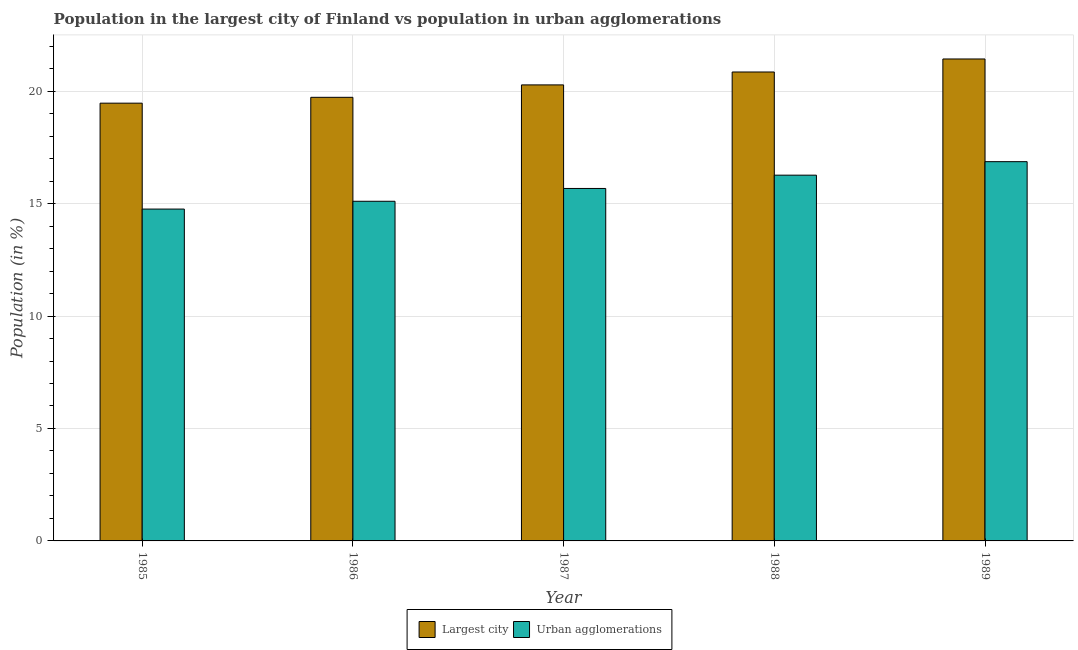Are the number of bars per tick equal to the number of legend labels?
Ensure brevity in your answer.  Yes. Are the number of bars on each tick of the X-axis equal?
Give a very brief answer. Yes. In how many cases, is the number of bars for a given year not equal to the number of legend labels?
Provide a succinct answer. 0. What is the population in the largest city in 1986?
Provide a short and direct response. 19.73. Across all years, what is the maximum population in urban agglomerations?
Give a very brief answer. 16.86. Across all years, what is the minimum population in urban agglomerations?
Your answer should be very brief. 14.76. In which year was the population in the largest city minimum?
Offer a very short reply. 1985. What is the total population in urban agglomerations in the graph?
Make the answer very short. 78.66. What is the difference between the population in urban agglomerations in 1988 and that in 1989?
Ensure brevity in your answer.  -0.6. What is the difference between the population in the largest city in 1985 and the population in urban agglomerations in 1989?
Give a very brief answer. -1.97. What is the average population in urban agglomerations per year?
Provide a succinct answer. 15.73. In the year 1986, what is the difference between the population in the largest city and population in urban agglomerations?
Give a very brief answer. 0. In how many years, is the population in the largest city greater than 4 %?
Give a very brief answer. 5. What is the ratio of the population in urban agglomerations in 1987 to that in 1989?
Your answer should be very brief. 0.93. Is the population in the largest city in 1987 less than that in 1988?
Your answer should be compact. Yes. What is the difference between the highest and the second highest population in urban agglomerations?
Provide a succinct answer. 0.6. What is the difference between the highest and the lowest population in the largest city?
Provide a short and direct response. 1.97. What does the 1st bar from the left in 1986 represents?
Provide a succinct answer. Largest city. What does the 2nd bar from the right in 1987 represents?
Your response must be concise. Largest city. How many years are there in the graph?
Your answer should be very brief. 5. Are the values on the major ticks of Y-axis written in scientific E-notation?
Offer a very short reply. No. Does the graph contain any zero values?
Provide a short and direct response. No. Does the graph contain grids?
Ensure brevity in your answer.  Yes. What is the title of the graph?
Offer a very short reply. Population in the largest city of Finland vs population in urban agglomerations. Does "Forest land" appear as one of the legend labels in the graph?
Your answer should be compact. No. What is the label or title of the Y-axis?
Ensure brevity in your answer.  Population (in %). What is the Population (in %) in Largest city in 1985?
Keep it short and to the point. 19.47. What is the Population (in %) in Urban agglomerations in 1985?
Provide a succinct answer. 14.76. What is the Population (in %) in Largest city in 1986?
Keep it short and to the point. 19.73. What is the Population (in %) of Urban agglomerations in 1986?
Offer a terse response. 15.1. What is the Population (in %) of Largest city in 1987?
Ensure brevity in your answer.  20.28. What is the Population (in %) in Urban agglomerations in 1987?
Offer a terse response. 15.67. What is the Population (in %) of Largest city in 1988?
Provide a succinct answer. 20.85. What is the Population (in %) in Urban agglomerations in 1988?
Your answer should be very brief. 16.26. What is the Population (in %) of Largest city in 1989?
Offer a terse response. 21.43. What is the Population (in %) in Urban agglomerations in 1989?
Your response must be concise. 16.86. Across all years, what is the maximum Population (in %) of Largest city?
Offer a very short reply. 21.43. Across all years, what is the maximum Population (in %) of Urban agglomerations?
Give a very brief answer. 16.86. Across all years, what is the minimum Population (in %) in Largest city?
Ensure brevity in your answer.  19.47. Across all years, what is the minimum Population (in %) in Urban agglomerations?
Provide a succinct answer. 14.76. What is the total Population (in %) in Largest city in the graph?
Offer a very short reply. 101.75. What is the total Population (in %) in Urban agglomerations in the graph?
Keep it short and to the point. 78.66. What is the difference between the Population (in %) of Largest city in 1985 and that in 1986?
Offer a very short reply. -0.26. What is the difference between the Population (in %) of Urban agglomerations in 1985 and that in 1986?
Keep it short and to the point. -0.35. What is the difference between the Population (in %) in Largest city in 1985 and that in 1987?
Keep it short and to the point. -0.81. What is the difference between the Population (in %) of Urban agglomerations in 1985 and that in 1987?
Make the answer very short. -0.92. What is the difference between the Population (in %) in Largest city in 1985 and that in 1988?
Give a very brief answer. -1.39. What is the difference between the Population (in %) in Urban agglomerations in 1985 and that in 1988?
Ensure brevity in your answer.  -1.51. What is the difference between the Population (in %) of Largest city in 1985 and that in 1989?
Your response must be concise. -1.97. What is the difference between the Population (in %) of Urban agglomerations in 1985 and that in 1989?
Offer a terse response. -2.11. What is the difference between the Population (in %) in Largest city in 1986 and that in 1987?
Provide a short and direct response. -0.55. What is the difference between the Population (in %) of Urban agglomerations in 1986 and that in 1987?
Provide a short and direct response. -0.57. What is the difference between the Population (in %) of Largest city in 1986 and that in 1988?
Provide a short and direct response. -1.13. What is the difference between the Population (in %) in Urban agglomerations in 1986 and that in 1988?
Ensure brevity in your answer.  -1.16. What is the difference between the Population (in %) in Largest city in 1986 and that in 1989?
Your answer should be very brief. -1.71. What is the difference between the Population (in %) in Urban agglomerations in 1986 and that in 1989?
Keep it short and to the point. -1.76. What is the difference between the Population (in %) of Largest city in 1987 and that in 1988?
Provide a succinct answer. -0.57. What is the difference between the Population (in %) of Urban agglomerations in 1987 and that in 1988?
Give a very brief answer. -0.59. What is the difference between the Population (in %) in Largest city in 1987 and that in 1989?
Provide a short and direct response. -1.15. What is the difference between the Population (in %) of Urban agglomerations in 1987 and that in 1989?
Offer a terse response. -1.19. What is the difference between the Population (in %) in Largest city in 1988 and that in 1989?
Ensure brevity in your answer.  -0.58. What is the difference between the Population (in %) of Urban agglomerations in 1988 and that in 1989?
Ensure brevity in your answer.  -0.6. What is the difference between the Population (in %) in Largest city in 1985 and the Population (in %) in Urban agglomerations in 1986?
Your response must be concise. 4.36. What is the difference between the Population (in %) of Largest city in 1985 and the Population (in %) of Urban agglomerations in 1987?
Give a very brief answer. 3.79. What is the difference between the Population (in %) of Largest city in 1985 and the Population (in %) of Urban agglomerations in 1988?
Your response must be concise. 3.2. What is the difference between the Population (in %) in Largest city in 1985 and the Population (in %) in Urban agglomerations in 1989?
Provide a short and direct response. 2.6. What is the difference between the Population (in %) of Largest city in 1986 and the Population (in %) of Urban agglomerations in 1987?
Provide a short and direct response. 4.05. What is the difference between the Population (in %) in Largest city in 1986 and the Population (in %) in Urban agglomerations in 1988?
Provide a succinct answer. 3.46. What is the difference between the Population (in %) in Largest city in 1986 and the Population (in %) in Urban agglomerations in 1989?
Provide a succinct answer. 2.86. What is the difference between the Population (in %) in Largest city in 1987 and the Population (in %) in Urban agglomerations in 1988?
Offer a very short reply. 4.01. What is the difference between the Population (in %) in Largest city in 1987 and the Population (in %) in Urban agglomerations in 1989?
Provide a succinct answer. 3.41. What is the difference between the Population (in %) in Largest city in 1988 and the Population (in %) in Urban agglomerations in 1989?
Provide a succinct answer. 3.99. What is the average Population (in %) of Largest city per year?
Offer a terse response. 20.35. What is the average Population (in %) of Urban agglomerations per year?
Keep it short and to the point. 15.73. In the year 1985, what is the difference between the Population (in %) of Largest city and Population (in %) of Urban agglomerations?
Provide a succinct answer. 4.71. In the year 1986, what is the difference between the Population (in %) in Largest city and Population (in %) in Urban agglomerations?
Provide a succinct answer. 4.62. In the year 1987, what is the difference between the Population (in %) in Largest city and Population (in %) in Urban agglomerations?
Offer a very short reply. 4.61. In the year 1988, what is the difference between the Population (in %) of Largest city and Population (in %) of Urban agglomerations?
Give a very brief answer. 4.59. In the year 1989, what is the difference between the Population (in %) in Largest city and Population (in %) in Urban agglomerations?
Provide a short and direct response. 4.57. What is the ratio of the Population (in %) of Largest city in 1985 to that in 1986?
Provide a succinct answer. 0.99. What is the ratio of the Population (in %) in Urban agglomerations in 1985 to that in 1986?
Provide a short and direct response. 0.98. What is the ratio of the Population (in %) of Largest city in 1985 to that in 1987?
Offer a terse response. 0.96. What is the ratio of the Population (in %) in Urban agglomerations in 1985 to that in 1987?
Offer a very short reply. 0.94. What is the ratio of the Population (in %) in Largest city in 1985 to that in 1988?
Your answer should be compact. 0.93. What is the ratio of the Population (in %) in Urban agglomerations in 1985 to that in 1988?
Provide a succinct answer. 0.91. What is the ratio of the Population (in %) of Largest city in 1985 to that in 1989?
Provide a short and direct response. 0.91. What is the ratio of the Population (in %) of Urban agglomerations in 1985 to that in 1989?
Give a very brief answer. 0.88. What is the ratio of the Population (in %) in Largest city in 1986 to that in 1987?
Give a very brief answer. 0.97. What is the ratio of the Population (in %) in Urban agglomerations in 1986 to that in 1987?
Your answer should be very brief. 0.96. What is the ratio of the Population (in %) of Largest city in 1986 to that in 1988?
Offer a terse response. 0.95. What is the ratio of the Population (in %) in Largest city in 1986 to that in 1989?
Your answer should be very brief. 0.92. What is the ratio of the Population (in %) of Urban agglomerations in 1986 to that in 1989?
Keep it short and to the point. 0.9. What is the ratio of the Population (in %) of Largest city in 1987 to that in 1988?
Your answer should be very brief. 0.97. What is the ratio of the Population (in %) of Urban agglomerations in 1987 to that in 1988?
Your answer should be compact. 0.96. What is the ratio of the Population (in %) in Largest city in 1987 to that in 1989?
Provide a short and direct response. 0.95. What is the ratio of the Population (in %) of Urban agglomerations in 1987 to that in 1989?
Your response must be concise. 0.93. What is the ratio of the Population (in %) in Largest city in 1988 to that in 1989?
Offer a very short reply. 0.97. What is the ratio of the Population (in %) of Urban agglomerations in 1988 to that in 1989?
Your answer should be very brief. 0.96. What is the difference between the highest and the second highest Population (in %) in Largest city?
Ensure brevity in your answer.  0.58. What is the difference between the highest and the second highest Population (in %) of Urban agglomerations?
Your answer should be compact. 0.6. What is the difference between the highest and the lowest Population (in %) of Largest city?
Offer a very short reply. 1.97. What is the difference between the highest and the lowest Population (in %) in Urban agglomerations?
Offer a terse response. 2.11. 